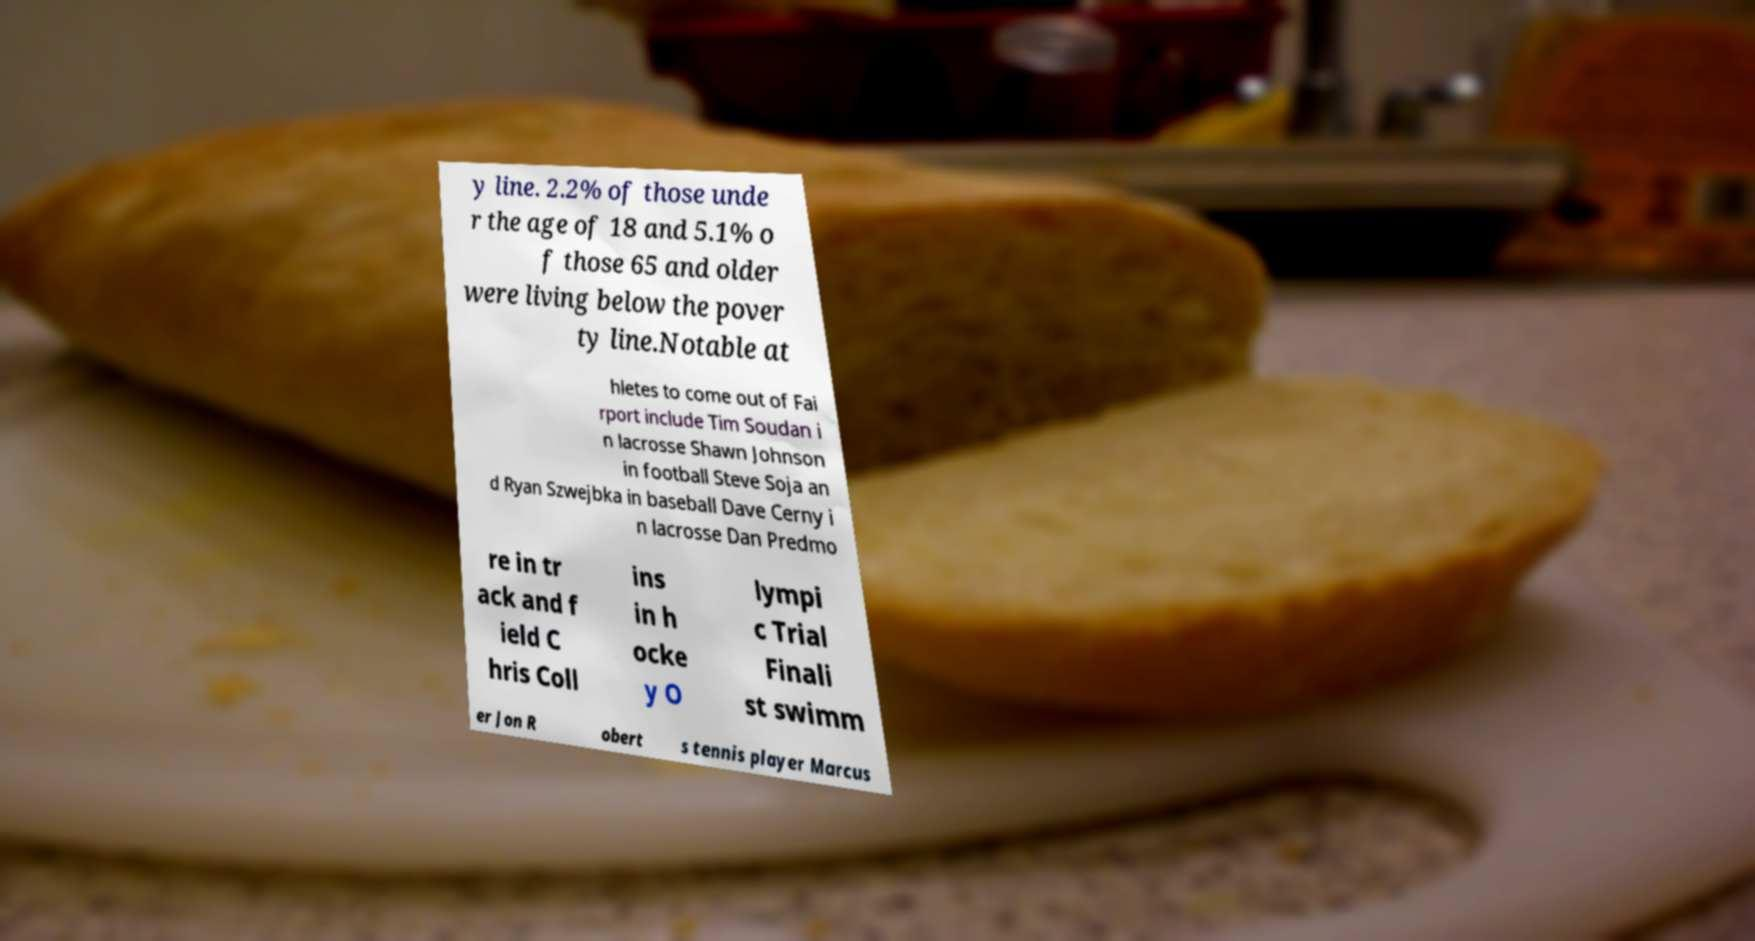There's text embedded in this image that I need extracted. Can you transcribe it verbatim? y line. 2.2% of those unde r the age of 18 and 5.1% o f those 65 and older were living below the pover ty line.Notable at hletes to come out of Fai rport include Tim Soudan i n lacrosse Shawn Johnson in football Steve Soja an d Ryan Szwejbka in baseball Dave Cerny i n lacrosse Dan Predmo re in tr ack and f ield C hris Coll ins in h ocke y O lympi c Trial Finali st swimm er Jon R obert s tennis player Marcus 